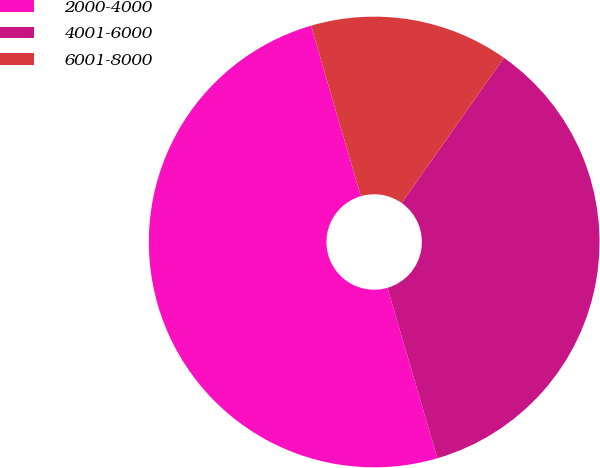Convert chart. <chart><loc_0><loc_0><loc_500><loc_500><pie_chart><fcel>2000-4000<fcel>4001-6000<fcel>6001-8000<nl><fcel>50.0%<fcel>35.71%<fcel>14.29%<nl></chart> 